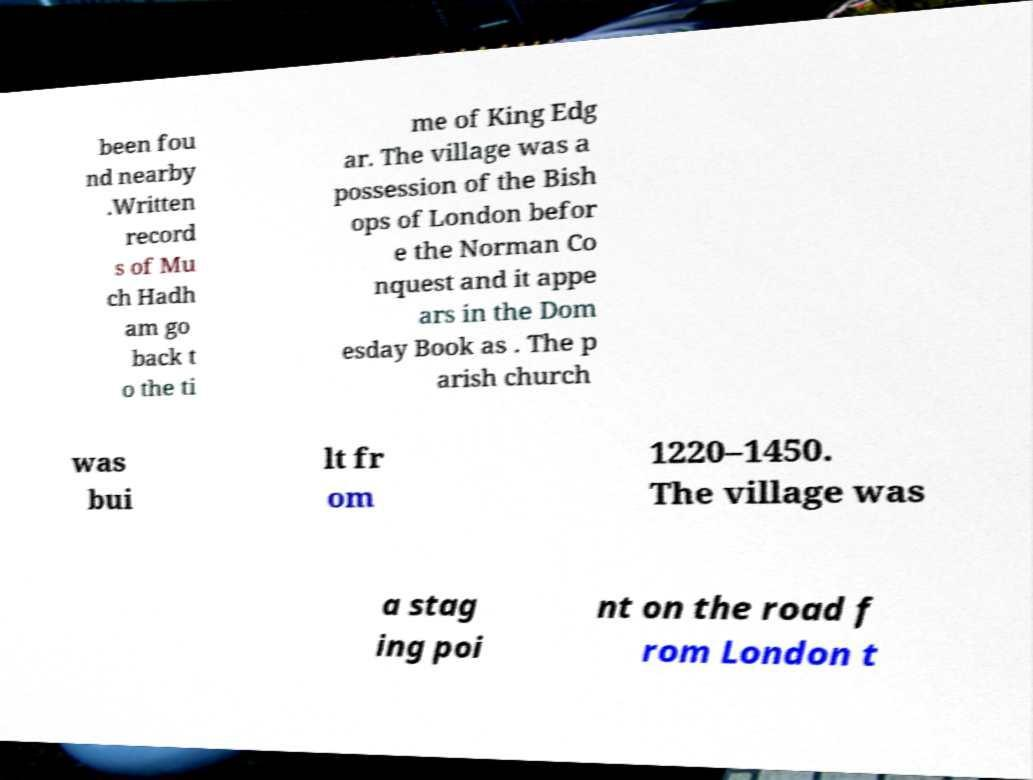Please read and relay the text visible in this image. What does it say? been fou nd nearby .Written record s of Mu ch Hadh am go back t o the ti me of King Edg ar. The village was a possession of the Bish ops of London befor e the Norman Co nquest and it appe ars in the Dom esday Book as . The p arish church was bui lt fr om 1220–1450. The village was a stag ing poi nt on the road f rom London t 